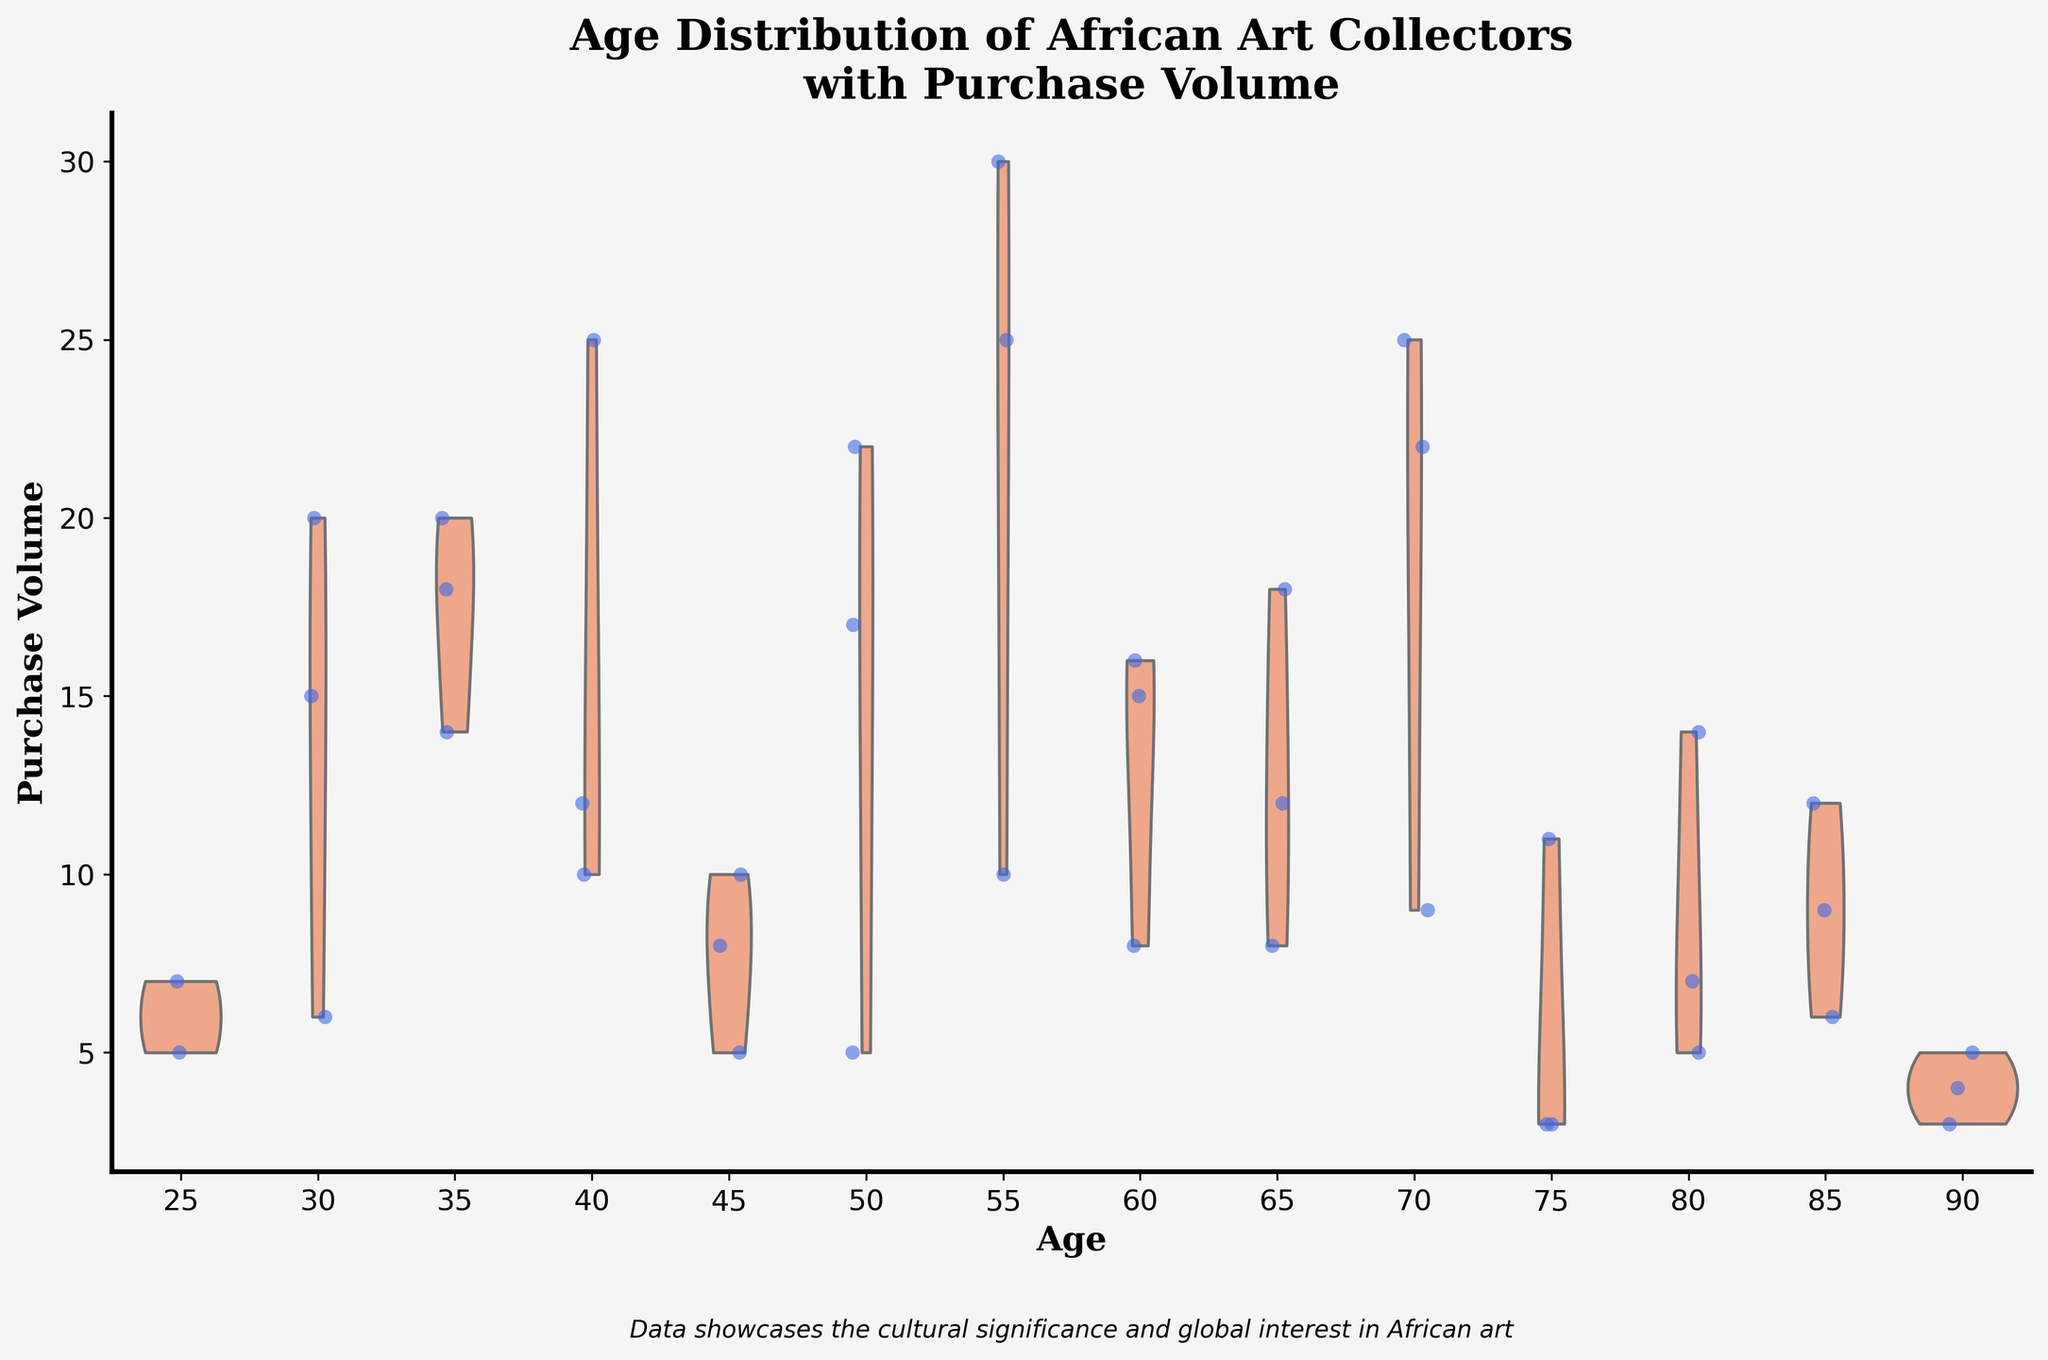What is the title of the figure? The title of the figure is prominently displayed at the top and is written in bold font. It reads "Age Distribution of African Art Collectors with Purchase Volume".
Answer: Age Distribution of African Art Collectors with Purchase Volume What are the labels on the x-axis and y-axis? The labels on the x-axis and y-axis help identify what each axis represents. The x-axis is labeled "Age" and the y-axis is labeled "Purchase Volume".
Answer: Age; Purchase Volume What is the general trend in Purchase Volume as the age of collectors increases? By observing the violin plots and jittered points, we see that although there is a wide range of Purchase Volumes across all ages, older collectors (particularly around the 55-70 age range) generally show higher Purchase Volumes, based on the density and spread of the points.
Answer: Older collectors show higher Purchase Volumes What can you say about the Purchase Volume for younger collectors (aged around 25-40)? Examining the violin plots and jittered points, younger collectors (ages 25-40) have considerably lower Purchase Volumes compared to older collectors. The data points for younger ages are concentrated at lower volumes.
Answer: Lower Purchase Volumes Which age group has the highest Purchase Volume and what is its approximate value? The violin plot with the highest peak and the jittered point spread around the 70 age mark shows the highest collective Purchase Volume. The highest individual Purchase Volume within this group is approximately 25.
Answer: 70, approximately 25 Compare the Purchase Volume between collectors aged 40 and 60. Which group has a higher maximum Purchase Volume? By comparing the violin plots for ages 40 and 60, we see there are high volumes for both ages, but the age 60 group has a maximum Purchase Volume represented by 16, while the age 40 group shows multiple collectors around 25. Thus, age 40's maximum is higher.
Answer: Age 40 has a higher maximum Is there a noticeable trend in the median Purchase Volume across different age groups? Observing the thickness and distribution of the violin plots, the median Purchase Volume appears to increase slightly as we move from younger to older age groups but shows high variability across all ages.
Answer: Median increases slightly with age but remains variable Which age group shows the widest distribution in Purchase Volumes? The violin plot for age 55 shows a widespread distribution of Purchase Volumes, indicating a significant variability compared to other age groups. This is depicted by its broad shape and multiple jittered points across a wider range.
Answer: Age 55 What is the approximate range of Purchase Volumes for collectors aged 50? For the age group of 50, by looking at the jittered points and the shape of the violin plot, we see that Purchase Volumes range approximately from 5 to 22.
Answer: 5 to 22 Are there any ages where the Purchase Volume is consistently low? The violin plots and jittered points for ages 25, 75, and 90 consistently show lower Purchase Volumes, with fewer high points in the data and more concentrations around lower values.
Answer: Ages 25, 75, and 90 